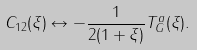Convert formula to latex. <formula><loc_0><loc_0><loc_500><loc_500>C _ { 1 2 } ( \xi ) \leftrightarrow - \frac { 1 } { 2 ( 1 + \xi ) } T ^ { a } _ { G } ( \xi ) .</formula> 